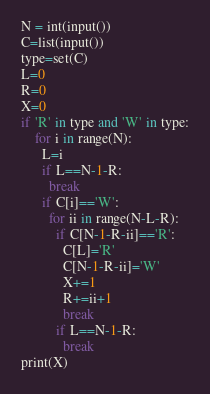Convert code to text. <code><loc_0><loc_0><loc_500><loc_500><_Python_>N = int(input())
C=list(input())
type=set(C)
L=0
R=0
X=0
if 'R' in type and 'W' in type:
    for i in range(N):
      L=i
      if L==N-1-R:
        break
      if C[i]=='W':
        for ii in range(N-L-R):
          if C[N-1-R-ii]=='R':
            C[L]='R'
            C[N-1-R-ii]='W'
            X+=1
            R+=ii+1
            break
          if L==N-1-R:
            break
print(X)</code> 